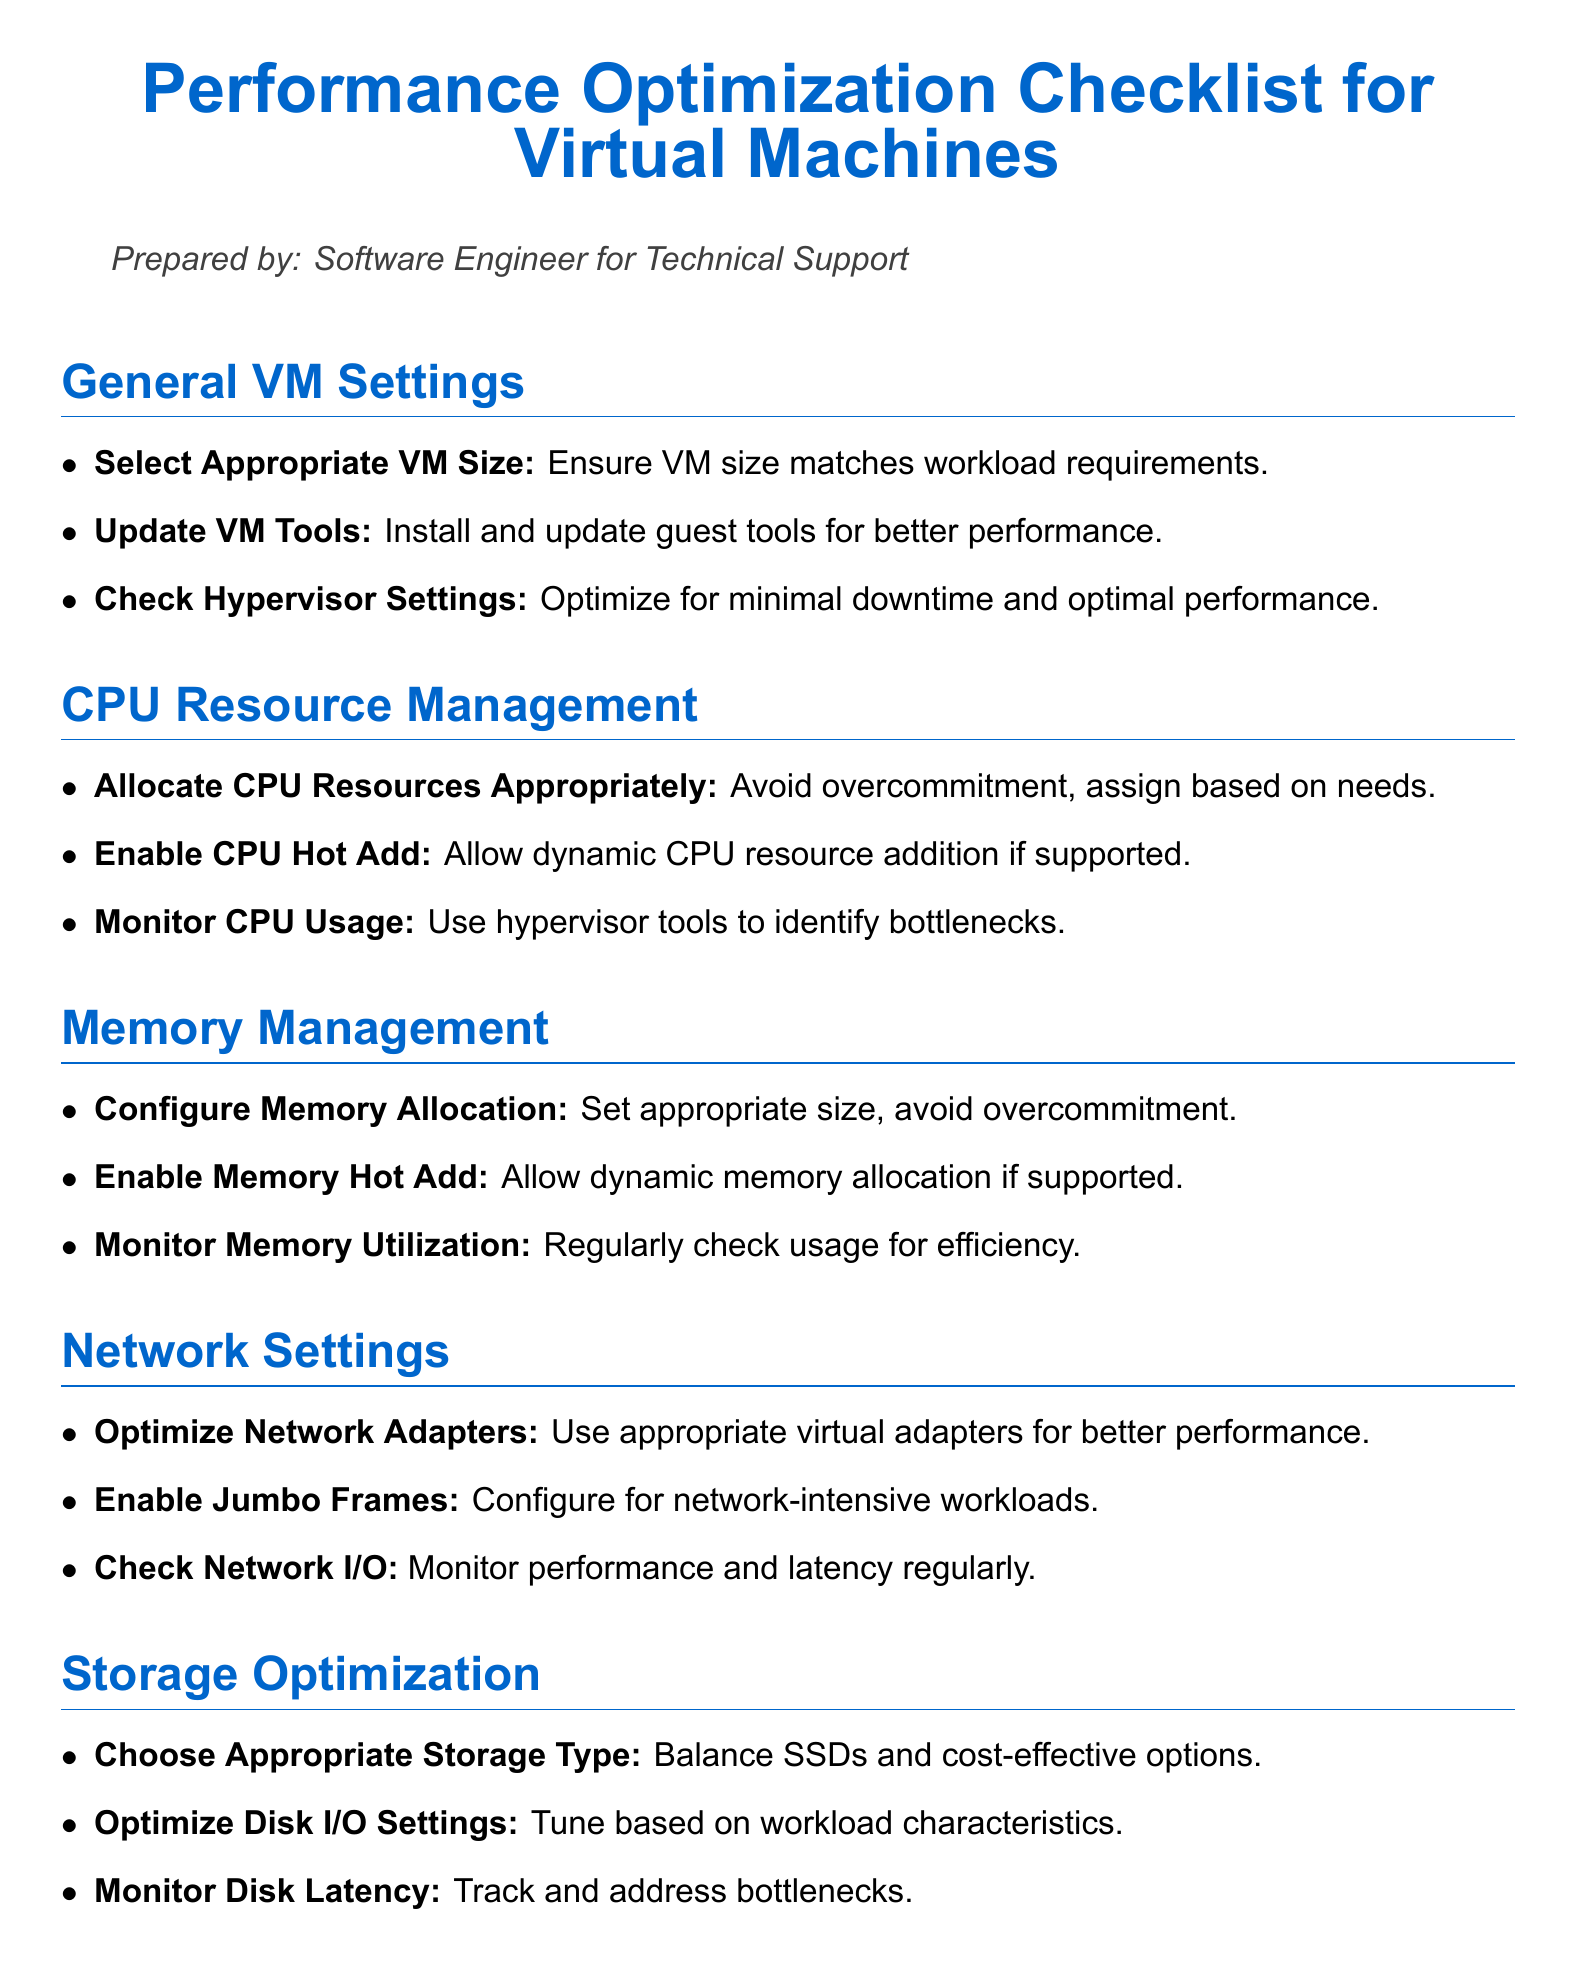what is the title of the document? The title of the document is prominently displayed at the top and describes the content focus.
Answer: Performance Optimization Checklist for Virtual Machines how many sections are there in the document? Each main topic is presented as a section in the document, each starting with a bold section title.
Answer: 6 what should be done to optimize network settings? The document lists specific actions related to network optimizations within the related section.
Answer: Optimize Network Adapters what does the document recommend for CPU resource management? The CPU management section contains various recommendations that fall under resource allocation and monitoring.
Answer: Monitor CPU Usage how should memory be allocated according to the checklist? Memory management involves ensuring efficiency while avoiding overcommitment, which is stated in the relevant section.
Answer: Set appropriate size, avoid overcommitment which configuration is suggested for storage optimization? The checklist specifies types of storage that would yield balanced performance and cost-effectiveness.
Answer: Choose Appropriate Storage Type 